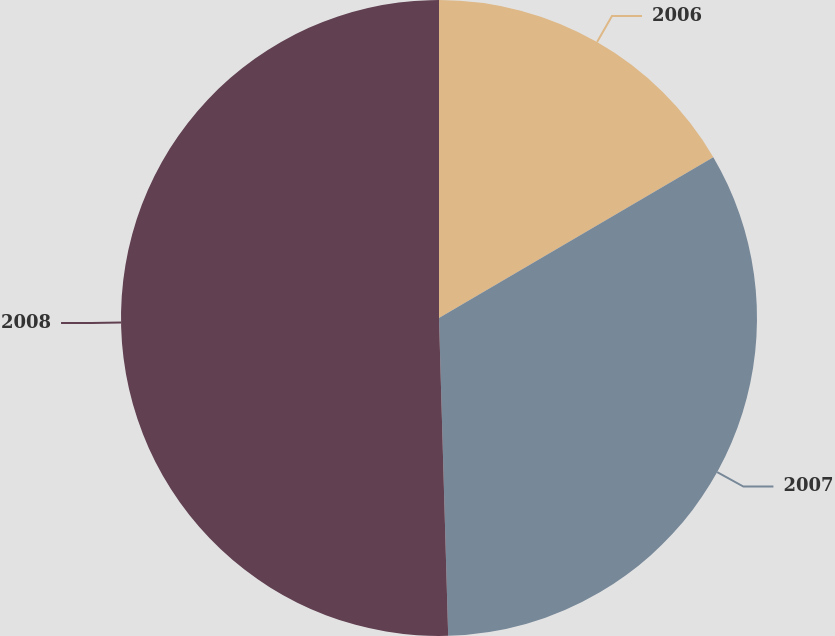Convert chart. <chart><loc_0><loc_0><loc_500><loc_500><pie_chart><fcel>2006<fcel>2007<fcel>2008<nl><fcel>16.56%<fcel>32.98%<fcel>50.46%<nl></chart> 